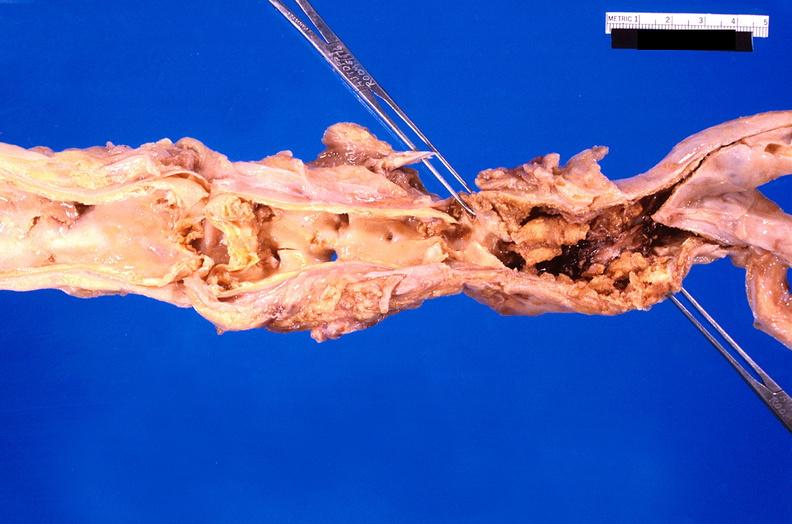where is this?
Answer the question using a single word or phrase. Aorta 